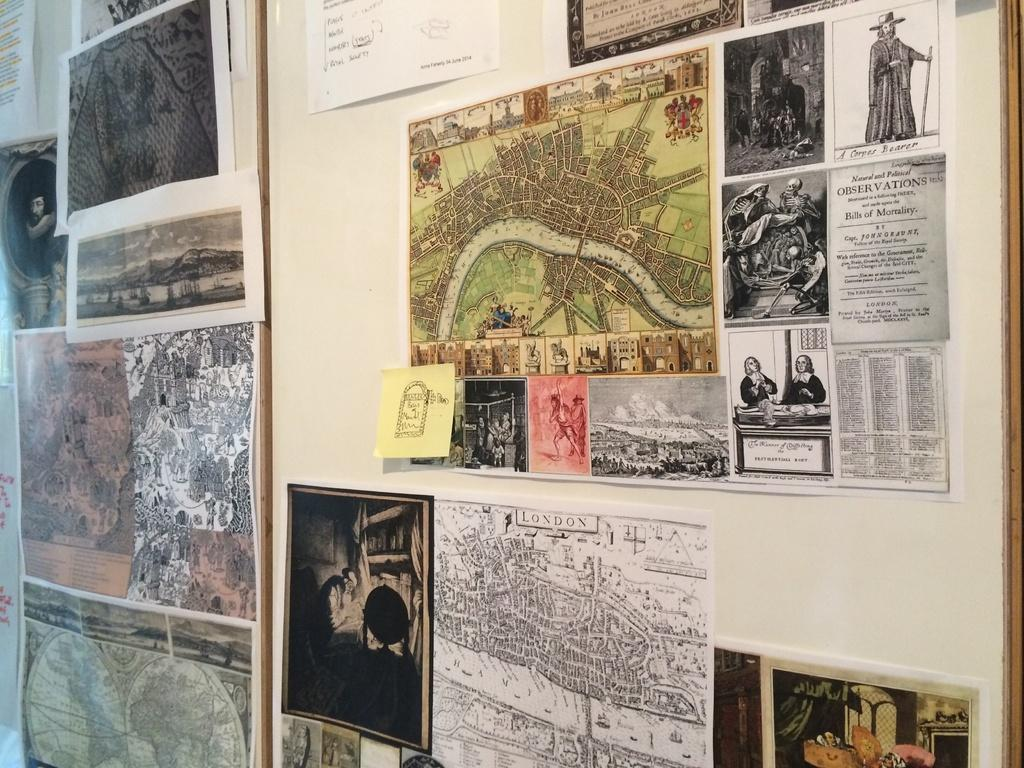What is the main object in the image? There is a board in the image. What is attached to the board? There are many posters on the board. What type of produce is hanging from the board in the image? There is no produce present in the image; it features a board with many posters. What vegetable is depicted on one of the posters? We cannot determine the content of the posters without seeing them, but there is no mention of a vegetable being depicted on any of the posters. 